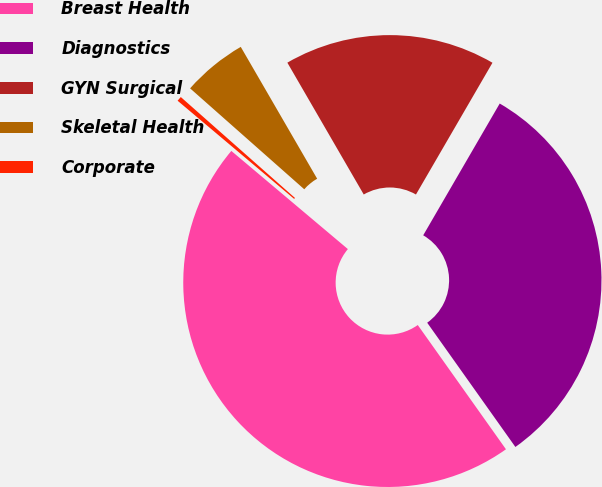Convert chart. <chart><loc_0><loc_0><loc_500><loc_500><pie_chart><fcel>Breast Health<fcel>Diagnostics<fcel>GYN Surgical<fcel>Skeletal Health<fcel>Corporate<nl><fcel>45.96%<fcel>31.8%<fcel>16.73%<fcel>5.12%<fcel>0.38%<nl></chart> 